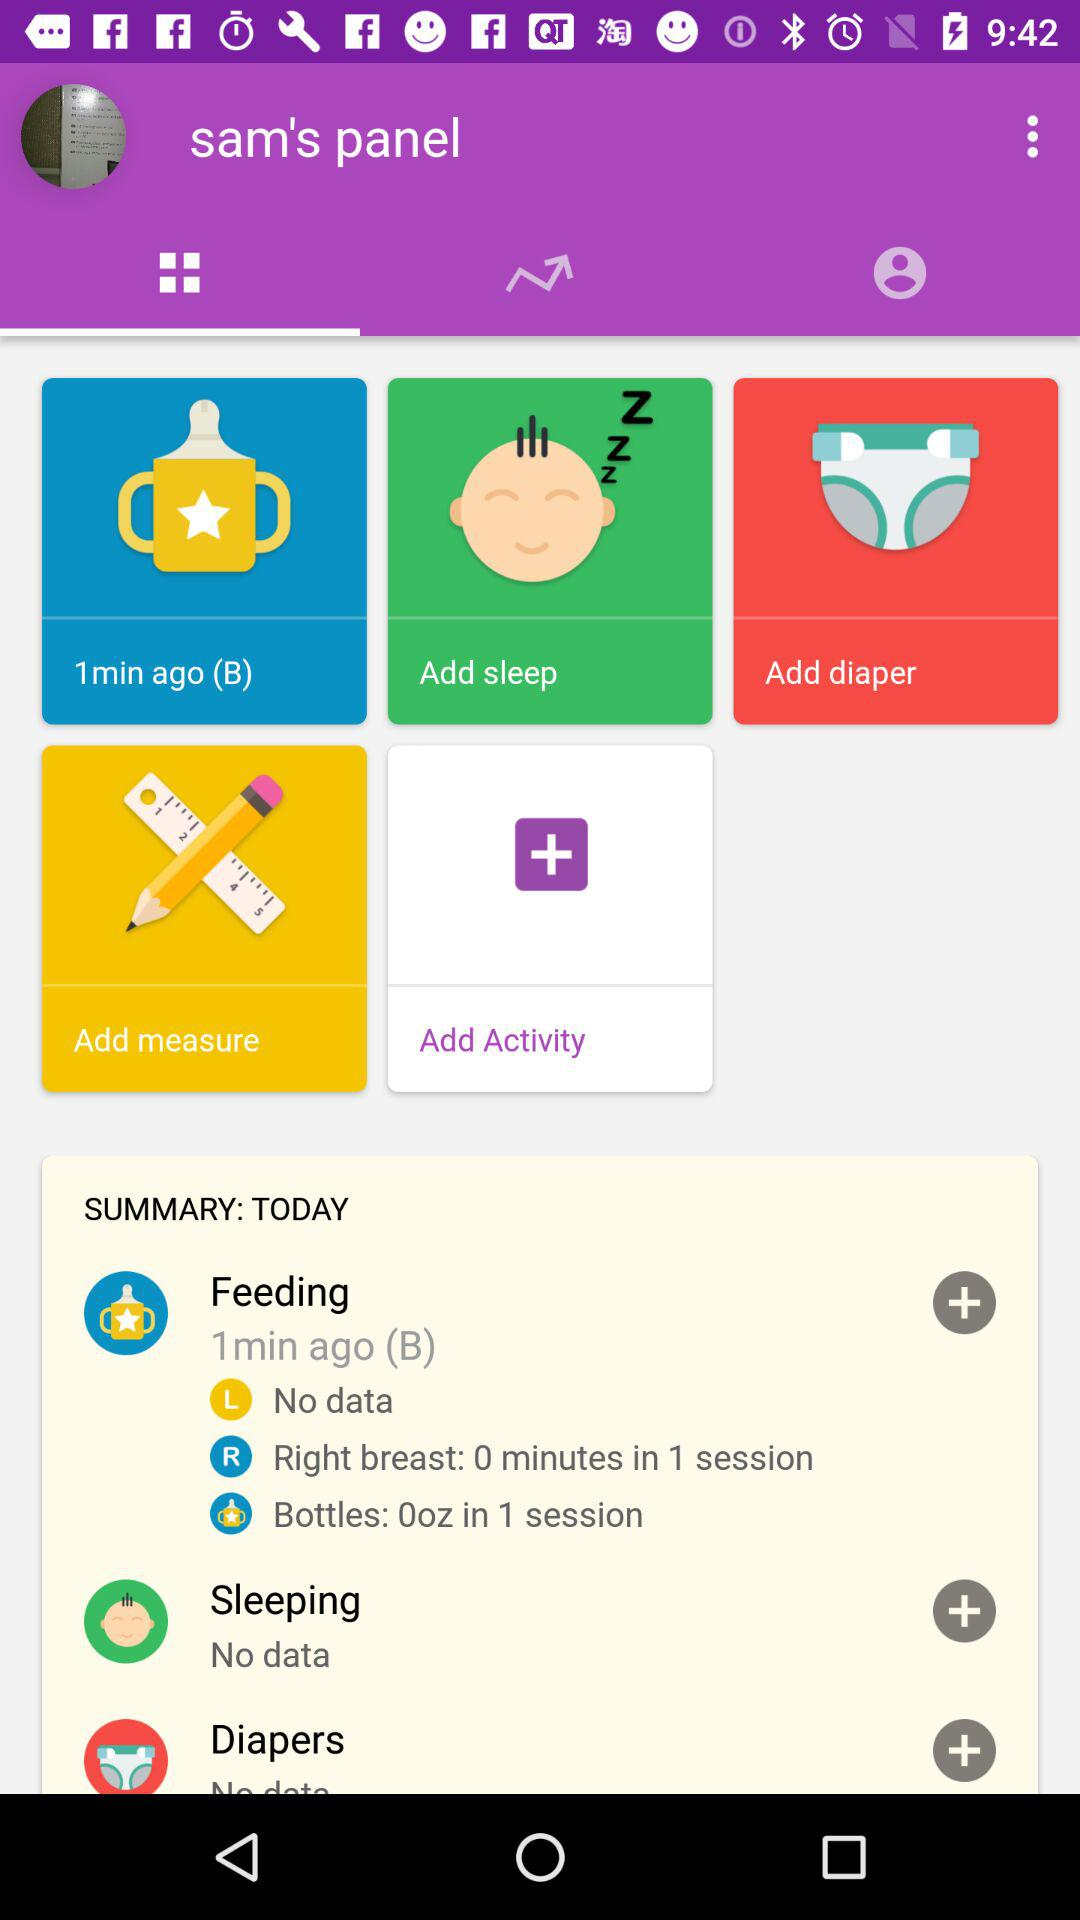How many minutes ago was the feeding completed? The feeding was completed 1 minute ago. 